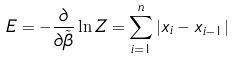<formula> <loc_0><loc_0><loc_500><loc_500>E = - \frac { \partial } { \partial \tilde { \beta } } \ln Z = \sum _ { i = 1 } ^ { n } \left | x _ { i } - x _ { i - 1 } \right |</formula> 